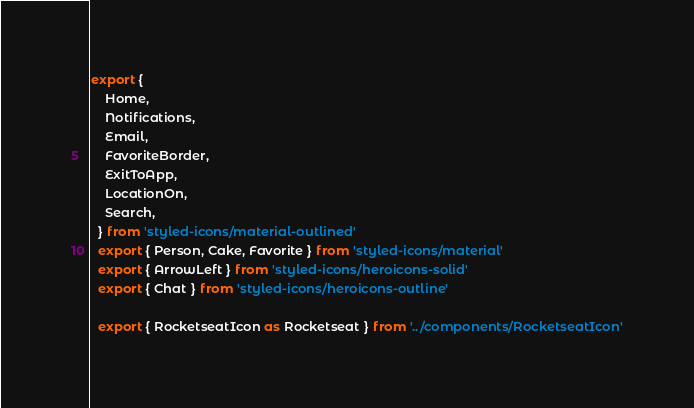<code> <loc_0><loc_0><loc_500><loc_500><_TypeScript_>export {
    Home,
    Notifications,
    Email,
    FavoriteBorder,
    ExitToApp,
    LocationOn,
    Search,
  } from 'styled-icons/material-outlined'
  export { Person, Cake, Favorite } from 'styled-icons/material'
  export { ArrowLeft } from 'styled-icons/heroicons-solid'
  export { Chat } from 'styled-icons/heroicons-outline'

  export { RocketseatIcon as Rocketseat } from '../components/RocketseatIcon'</code> 